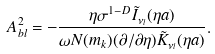<formula> <loc_0><loc_0><loc_500><loc_500>A _ { b l } ^ { 2 } = - \frac { \eta \sigma ^ { 1 - D } \tilde { I } _ { \nu _ { l } } ( \eta a ) } { \omega N ( m _ { k } ) ( \partial / \partial \eta ) \tilde { K } _ { \nu _ { l } } ( \eta a ) } .</formula> 